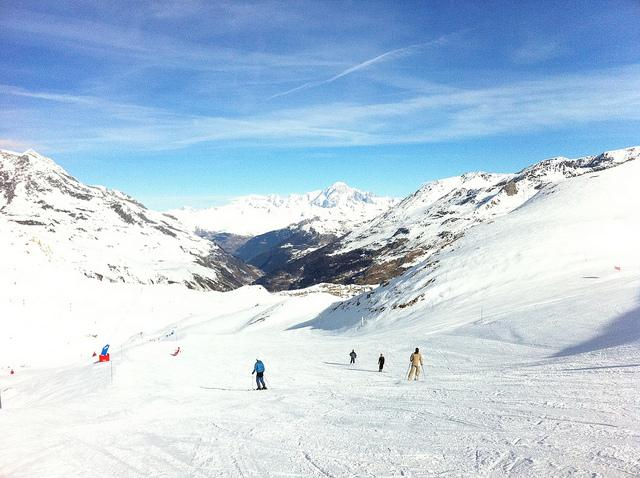What type of sport is this?

Choices:
A) winter
B) tropical
C) summer
D) aquatic winter 